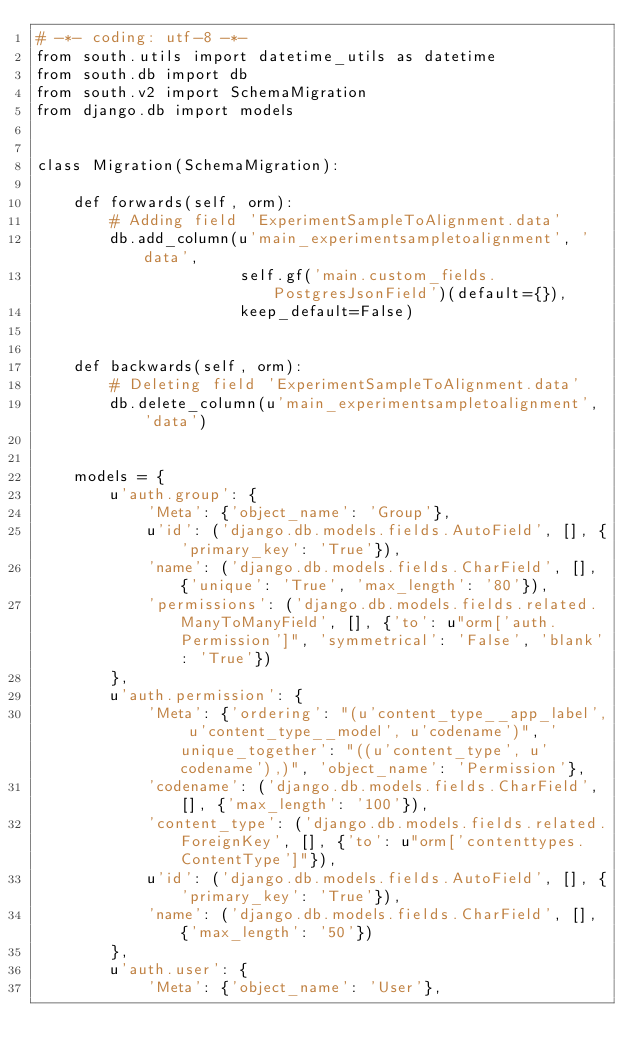Convert code to text. <code><loc_0><loc_0><loc_500><loc_500><_Python_># -*- coding: utf-8 -*-
from south.utils import datetime_utils as datetime
from south.db import db
from south.v2 import SchemaMigration
from django.db import models


class Migration(SchemaMigration):

    def forwards(self, orm):
        # Adding field 'ExperimentSampleToAlignment.data'
        db.add_column(u'main_experimentsampletoalignment', 'data',
                      self.gf('main.custom_fields.PostgresJsonField')(default={}),
                      keep_default=False)


    def backwards(self, orm):
        # Deleting field 'ExperimentSampleToAlignment.data'
        db.delete_column(u'main_experimentsampletoalignment', 'data')


    models = {
        u'auth.group': {
            'Meta': {'object_name': 'Group'},
            u'id': ('django.db.models.fields.AutoField', [], {'primary_key': 'True'}),
            'name': ('django.db.models.fields.CharField', [], {'unique': 'True', 'max_length': '80'}),
            'permissions': ('django.db.models.fields.related.ManyToManyField', [], {'to': u"orm['auth.Permission']", 'symmetrical': 'False', 'blank': 'True'})
        },
        u'auth.permission': {
            'Meta': {'ordering': "(u'content_type__app_label', u'content_type__model', u'codename')", 'unique_together': "((u'content_type', u'codename'),)", 'object_name': 'Permission'},
            'codename': ('django.db.models.fields.CharField', [], {'max_length': '100'}),
            'content_type': ('django.db.models.fields.related.ForeignKey', [], {'to': u"orm['contenttypes.ContentType']"}),
            u'id': ('django.db.models.fields.AutoField', [], {'primary_key': 'True'}),
            'name': ('django.db.models.fields.CharField', [], {'max_length': '50'})
        },
        u'auth.user': {
            'Meta': {'object_name': 'User'},</code> 